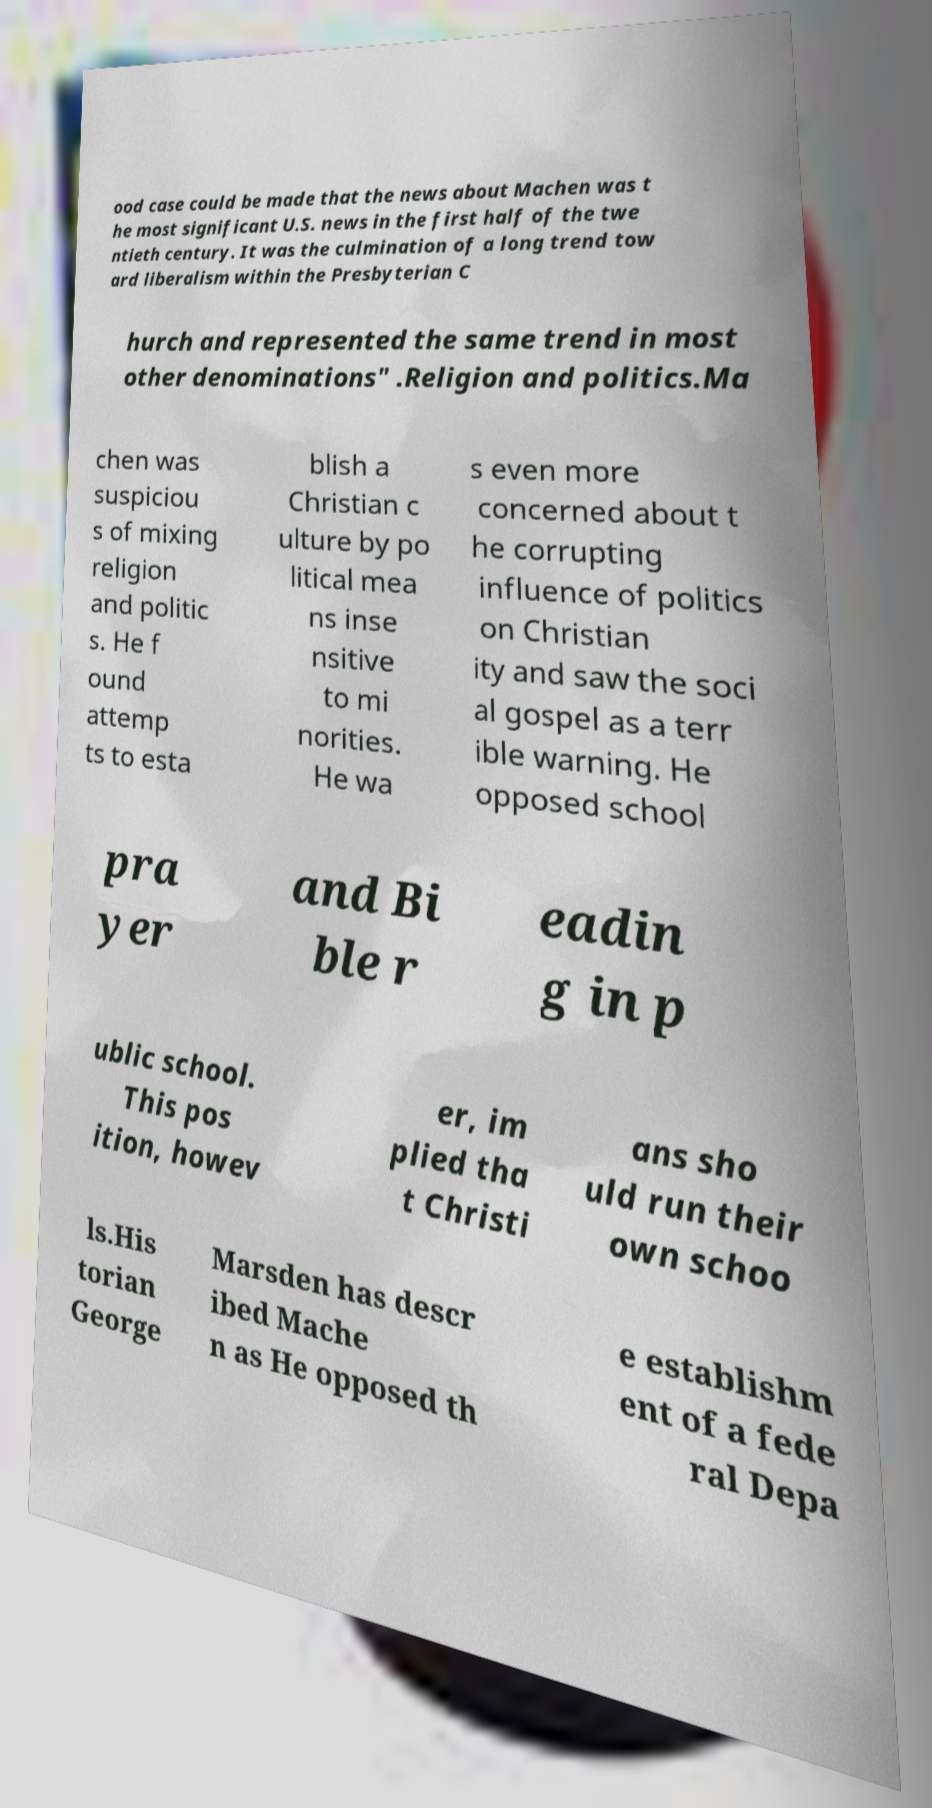What messages or text are displayed in this image? I need them in a readable, typed format. ood case could be made that the news about Machen was t he most significant U.S. news in the first half of the twe ntieth century. It was the culmination of a long trend tow ard liberalism within the Presbyterian C hurch and represented the same trend in most other denominations" .Religion and politics.Ma chen was suspiciou s of mixing religion and politic s. He f ound attemp ts to esta blish a Christian c ulture by po litical mea ns inse nsitive to mi norities. He wa s even more concerned about t he corrupting influence of politics on Christian ity and saw the soci al gospel as a terr ible warning. He opposed school pra yer and Bi ble r eadin g in p ublic school. This pos ition, howev er, im plied tha t Christi ans sho uld run their own schoo ls.His torian George Marsden has descr ibed Mache n as He opposed th e establishm ent of a fede ral Depa 